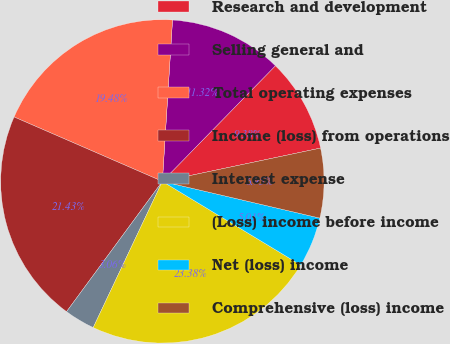Convert chart. <chart><loc_0><loc_0><loc_500><loc_500><pie_chart><fcel>Research and development<fcel>Selling general and<fcel>Total operating expenses<fcel>Income (loss) from operations<fcel>Interest expense<fcel>(Loss) income before income<fcel>Net (loss) income<fcel>Comprehensive (loss) income<nl><fcel>9.38%<fcel>11.32%<fcel>19.48%<fcel>21.43%<fcel>3.06%<fcel>23.38%<fcel>5.01%<fcel>6.95%<nl></chart> 